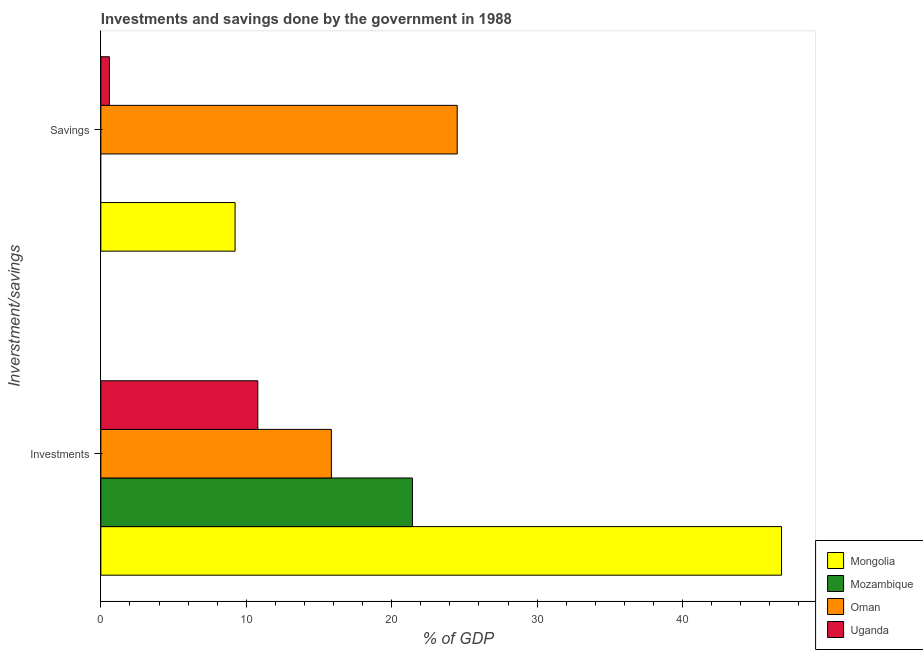How many different coloured bars are there?
Offer a very short reply. 4. How many groups of bars are there?
Give a very brief answer. 2. Are the number of bars on each tick of the Y-axis equal?
Your response must be concise. No. What is the label of the 1st group of bars from the top?
Make the answer very short. Savings. What is the investments of government in Mongolia?
Provide a succinct answer. 46.8. Across all countries, what is the maximum investments of government?
Your answer should be very brief. 46.8. Across all countries, what is the minimum investments of government?
Keep it short and to the point. 10.79. In which country was the investments of government maximum?
Offer a terse response. Mongolia. What is the total investments of government in the graph?
Offer a very short reply. 94.87. What is the difference between the investments of government in Mongolia and that in Uganda?
Your response must be concise. 36.01. What is the difference between the investments of government in Oman and the savings of government in Mozambique?
Provide a short and direct response. 15.85. What is the average investments of government per country?
Keep it short and to the point. 23.72. What is the difference between the savings of government and investments of government in Mongolia?
Ensure brevity in your answer.  -37.57. What is the ratio of the savings of government in Mongolia to that in Oman?
Provide a short and direct response. 0.38. Are all the bars in the graph horizontal?
Provide a succinct answer. Yes. How many countries are there in the graph?
Offer a very short reply. 4. Are the values on the major ticks of X-axis written in scientific E-notation?
Offer a very short reply. No. How many legend labels are there?
Your answer should be compact. 4. What is the title of the graph?
Provide a succinct answer. Investments and savings done by the government in 1988. Does "Gambia, The" appear as one of the legend labels in the graph?
Offer a terse response. No. What is the label or title of the X-axis?
Provide a succinct answer. % of GDP. What is the label or title of the Y-axis?
Offer a very short reply. Inverstment/savings. What is the % of GDP in Mongolia in Investments?
Keep it short and to the point. 46.8. What is the % of GDP of Mozambique in Investments?
Offer a terse response. 21.43. What is the % of GDP in Oman in Investments?
Your response must be concise. 15.85. What is the % of GDP of Uganda in Investments?
Ensure brevity in your answer.  10.79. What is the % of GDP of Mongolia in Savings?
Ensure brevity in your answer.  9.23. What is the % of GDP of Mozambique in Savings?
Keep it short and to the point. 0. What is the % of GDP of Oman in Savings?
Your answer should be very brief. 24.5. What is the % of GDP in Uganda in Savings?
Ensure brevity in your answer.  0.59. Across all Inverstment/savings, what is the maximum % of GDP of Mongolia?
Offer a terse response. 46.8. Across all Inverstment/savings, what is the maximum % of GDP in Mozambique?
Your answer should be compact. 21.43. Across all Inverstment/savings, what is the maximum % of GDP in Oman?
Offer a terse response. 24.5. Across all Inverstment/savings, what is the maximum % of GDP in Uganda?
Make the answer very short. 10.79. Across all Inverstment/savings, what is the minimum % of GDP in Mongolia?
Offer a terse response. 9.23. Across all Inverstment/savings, what is the minimum % of GDP in Mozambique?
Ensure brevity in your answer.  0. Across all Inverstment/savings, what is the minimum % of GDP in Oman?
Provide a succinct answer. 15.85. Across all Inverstment/savings, what is the minimum % of GDP of Uganda?
Your answer should be compact. 0.59. What is the total % of GDP of Mongolia in the graph?
Offer a very short reply. 56.03. What is the total % of GDP in Mozambique in the graph?
Provide a short and direct response. 21.43. What is the total % of GDP in Oman in the graph?
Offer a terse response. 40.35. What is the total % of GDP of Uganda in the graph?
Your answer should be very brief. 11.38. What is the difference between the % of GDP of Mongolia in Investments and that in Savings?
Your response must be concise. 37.57. What is the difference between the % of GDP of Oman in Investments and that in Savings?
Your answer should be compact. -8.65. What is the difference between the % of GDP in Uganda in Investments and that in Savings?
Give a very brief answer. 10.2. What is the difference between the % of GDP in Mongolia in Investments and the % of GDP in Oman in Savings?
Give a very brief answer. 22.3. What is the difference between the % of GDP in Mongolia in Investments and the % of GDP in Uganda in Savings?
Your answer should be very brief. 46.22. What is the difference between the % of GDP in Mozambique in Investments and the % of GDP in Oman in Savings?
Offer a very short reply. -3.08. What is the difference between the % of GDP in Mozambique in Investments and the % of GDP in Uganda in Savings?
Make the answer very short. 20.84. What is the difference between the % of GDP in Oman in Investments and the % of GDP in Uganda in Savings?
Ensure brevity in your answer.  15.26. What is the average % of GDP of Mongolia per Inverstment/savings?
Give a very brief answer. 28.02. What is the average % of GDP in Mozambique per Inverstment/savings?
Make the answer very short. 10.71. What is the average % of GDP in Oman per Inverstment/savings?
Your response must be concise. 20.18. What is the average % of GDP in Uganda per Inverstment/savings?
Your answer should be compact. 5.69. What is the difference between the % of GDP in Mongolia and % of GDP in Mozambique in Investments?
Keep it short and to the point. 25.38. What is the difference between the % of GDP in Mongolia and % of GDP in Oman in Investments?
Offer a terse response. 30.95. What is the difference between the % of GDP in Mongolia and % of GDP in Uganda in Investments?
Offer a very short reply. 36.01. What is the difference between the % of GDP of Mozambique and % of GDP of Oman in Investments?
Make the answer very short. 5.58. What is the difference between the % of GDP in Mozambique and % of GDP in Uganda in Investments?
Offer a very short reply. 10.63. What is the difference between the % of GDP in Oman and % of GDP in Uganda in Investments?
Your answer should be compact. 5.06. What is the difference between the % of GDP of Mongolia and % of GDP of Oman in Savings?
Offer a terse response. -15.27. What is the difference between the % of GDP in Mongolia and % of GDP in Uganda in Savings?
Your answer should be very brief. 8.64. What is the difference between the % of GDP of Oman and % of GDP of Uganda in Savings?
Offer a terse response. 23.92. What is the ratio of the % of GDP in Mongolia in Investments to that in Savings?
Your response must be concise. 5.07. What is the ratio of the % of GDP in Oman in Investments to that in Savings?
Provide a short and direct response. 0.65. What is the ratio of the % of GDP of Uganda in Investments to that in Savings?
Keep it short and to the point. 18.37. What is the difference between the highest and the second highest % of GDP of Mongolia?
Offer a terse response. 37.57. What is the difference between the highest and the second highest % of GDP of Oman?
Provide a succinct answer. 8.65. What is the difference between the highest and the second highest % of GDP of Uganda?
Give a very brief answer. 10.2. What is the difference between the highest and the lowest % of GDP in Mongolia?
Offer a very short reply. 37.57. What is the difference between the highest and the lowest % of GDP of Mozambique?
Offer a terse response. 21.43. What is the difference between the highest and the lowest % of GDP of Oman?
Keep it short and to the point. 8.65. What is the difference between the highest and the lowest % of GDP in Uganda?
Offer a very short reply. 10.2. 